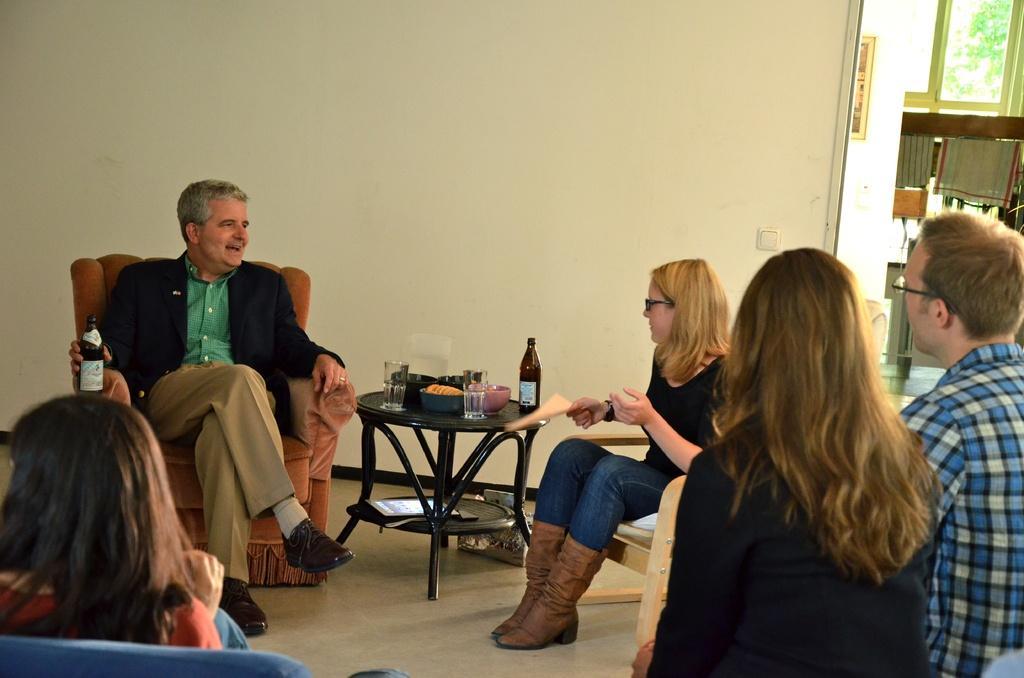Please provide a concise description of this image. In this picture we can see one man in middle sitting on chair and holding bottle in one hand and smiling and in front of him we can see some more persons sitting and talking and here on table we can see glass, bottle, bowls, tab and in background we can see wall, cloth hanger on wooden plank. 